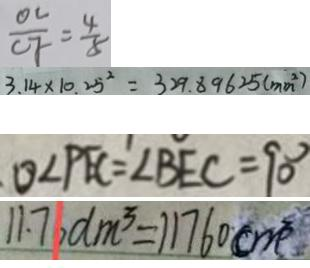Convert formula to latex. <formula><loc_0><loc_0><loc_500><loc_500>\frac { O C } { C F } = \frac { 4 } { 8 } 
 3 . 1 4 \times 1 0 . 2 5 ^ { 2 } = 3 2 9 . 8 9 6 2 5 ( m m ^ { 2 } ) 
 O \angle P E C = \angle B E C = 9 0 ^ { \circ } 
 1 1 . 7 6 d m ^ { 3 } = 1 1 7 6 0 c m ^ { 3 }</formula> 